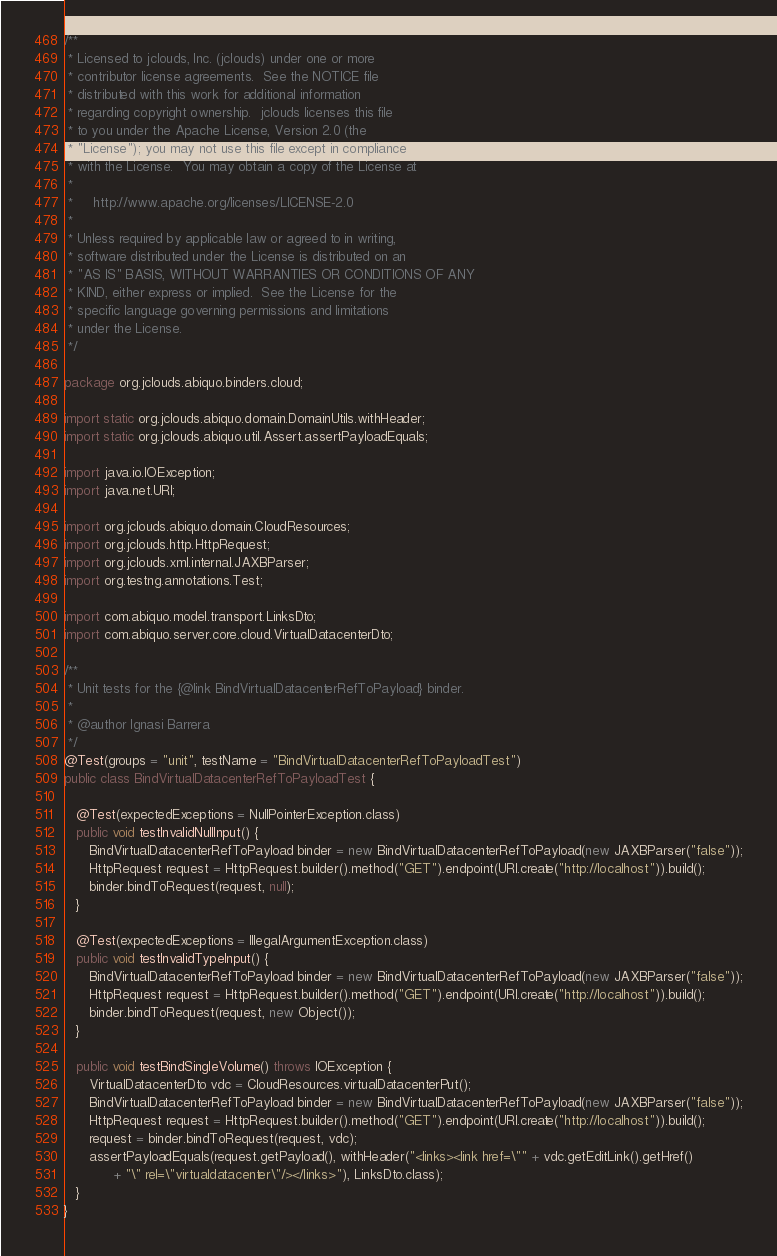<code> <loc_0><loc_0><loc_500><loc_500><_Java_>/**
 * Licensed to jclouds, Inc. (jclouds) under one or more
 * contributor license agreements.  See the NOTICE file
 * distributed with this work for additional information
 * regarding copyright ownership.  jclouds licenses this file
 * to you under the Apache License, Version 2.0 (the
 * "License"); you may not use this file except in compliance
 * with the License.  You may obtain a copy of the License at
 *
 *     http://www.apache.org/licenses/LICENSE-2.0
 *
 * Unless required by applicable law or agreed to in writing,
 * software distributed under the License is distributed on an
 * "AS IS" BASIS, WITHOUT WARRANTIES OR CONDITIONS OF ANY
 * KIND, either express or implied.  See the License for the
 * specific language governing permissions and limitations
 * under the License.
 */

package org.jclouds.abiquo.binders.cloud;

import static org.jclouds.abiquo.domain.DomainUtils.withHeader;
import static org.jclouds.abiquo.util.Assert.assertPayloadEquals;

import java.io.IOException;
import java.net.URI;

import org.jclouds.abiquo.domain.CloudResources;
import org.jclouds.http.HttpRequest;
import org.jclouds.xml.internal.JAXBParser;
import org.testng.annotations.Test;

import com.abiquo.model.transport.LinksDto;
import com.abiquo.server.core.cloud.VirtualDatacenterDto;

/**
 * Unit tests for the {@link BindVirtualDatacenterRefToPayload} binder.
 * 
 * @author Ignasi Barrera
 */
@Test(groups = "unit", testName = "BindVirtualDatacenterRefToPayloadTest")
public class BindVirtualDatacenterRefToPayloadTest {

   @Test(expectedExceptions = NullPointerException.class)
   public void testInvalidNullInput() {
      BindVirtualDatacenterRefToPayload binder = new BindVirtualDatacenterRefToPayload(new JAXBParser("false"));
      HttpRequest request = HttpRequest.builder().method("GET").endpoint(URI.create("http://localhost")).build();
      binder.bindToRequest(request, null);
   }

   @Test(expectedExceptions = IllegalArgumentException.class)
   public void testInvalidTypeInput() {
      BindVirtualDatacenterRefToPayload binder = new BindVirtualDatacenterRefToPayload(new JAXBParser("false"));
      HttpRequest request = HttpRequest.builder().method("GET").endpoint(URI.create("http://localhost")).build();
      binder.bindToRequest(request, new Object());
   }

   public void testBindSingleVolume() throws IOException {
      VirtualDatacenterDto vdc = CloudResources.virtualDatacenterPut();
      BindVirtualDatacenterRefToPayload binder = new BindVirtualDatacenterRefToPayload(new JAXBParser("false"));
      HttpRequest request = HttpRequest.builder().method("GET").endpoint(URI.create("http://localhost")).build();
      request = binder.bindToRequest(request, vdc);
      assertPayloadEquals(request.getPayload(), withHeader("<links><link href=\"" + vdc.getEditLink().getHref()
            + "\" rel=\"virtualdatacenter\"/></links>"), LinksDto.class);
   }
}
</code> 